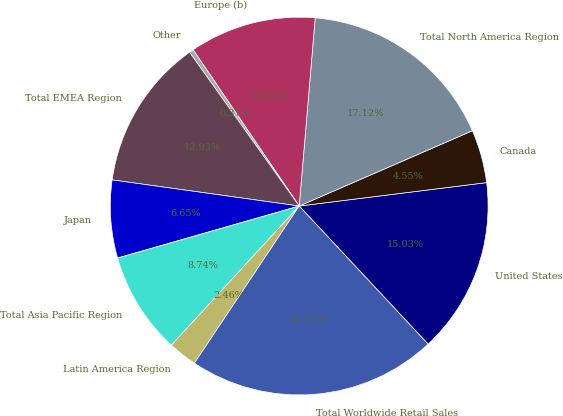Convert chart. <chart><loc_0><loc_0><loc_500><loc_500><pie_chart><fcel>United States<fcel>Canada<fcel>Total North America Region<fcel>Europe (b)<fcel>Other<fcel>Total EMEA Region<fcel>Japan<fcel>Total Asia Pacific Region<fcel>Latin America Region<fcel>Total Worldwide Retail Sales<nl><fcel>15.03%<fcel>4.55%<fcel>17.12%<fcel>10.84%<fcel>0.37%<fcel>12.93%<fcel>6.65%<fcel>8.74%<fcel>2.46%<fcel>21.31%<nl></chart> 